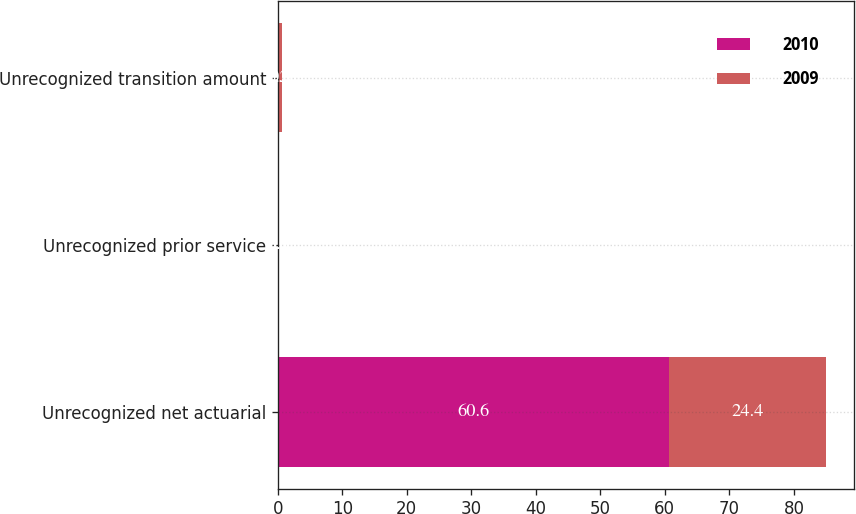Convert chart. <chart><loc_0><loc_0><loc_500><loc_500><stacked_bar_chart><ecel><fcel>Unrecognized net actuarial<fcel>Unrecognized prior service<fcel>Unrecognized transition amount<nl><fcel>2010<fcel>60.6<fcel>0.1<fcel>0.2<nl><fcel>2009<fcel>24.4<fcel>0.1<fcel>0.5<nl></chart> 